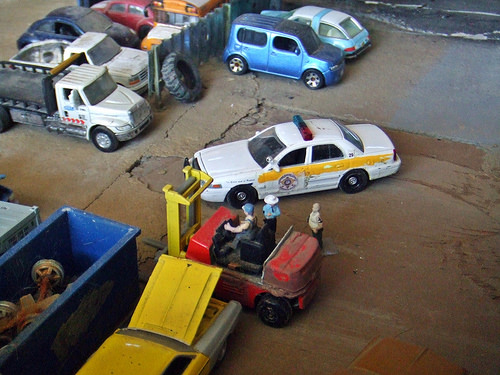<image>
Can you confirm if the person is to the right of the car? No. The person is not to the right of the car. The horizontal positioning shows a different relationship. Is there a cop car in the cop? No. The cop car is not contained within the cop. These objects have a different spatial relationship. 